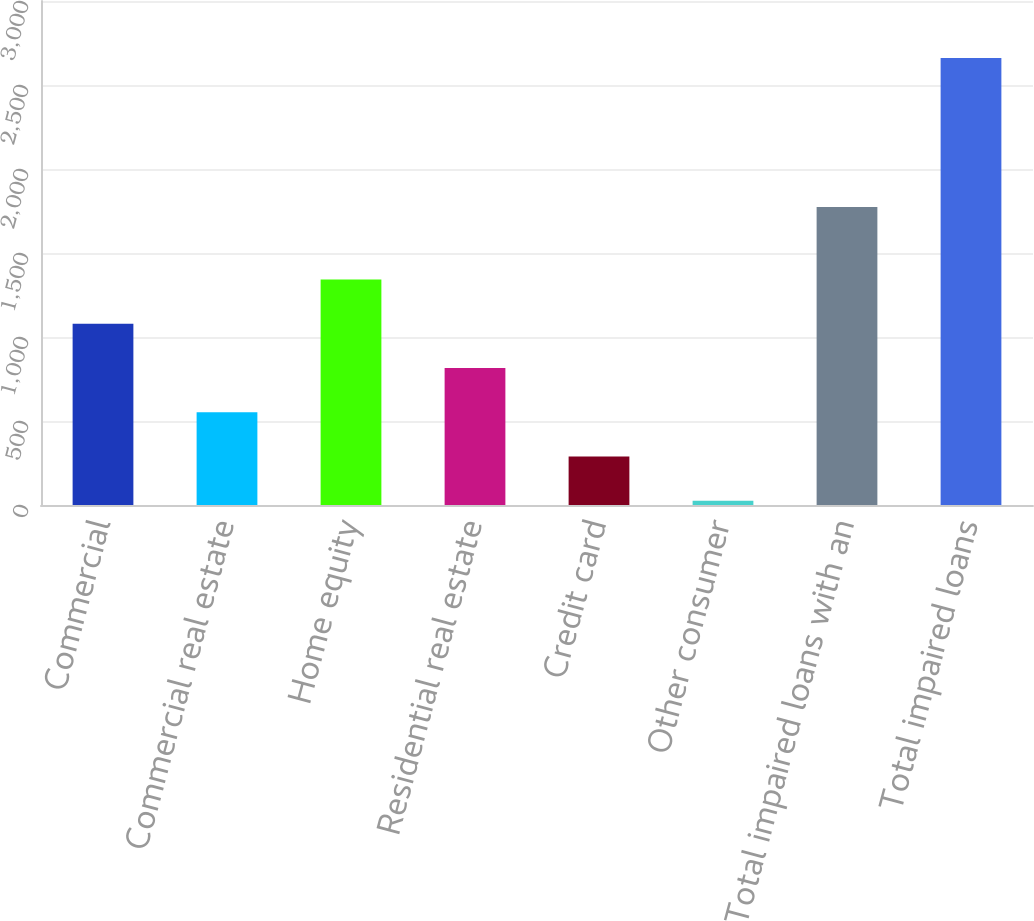Convert chart. <chart><loc_0><loc_0><loc_500><loc_500><bar_chart><fcel>Commercial<fcel>Commercial real estate<fcel>Home equity<fcel>Residential real estate<fcel>Credit card<fcel>Other consumer<fcel>Total impaired loans with an<fcel>Total impaired loans<nl><fcel>1079.6<fcel>552.8<fcel>1343<fcel>816.2<fcel>289.4<fcel>26<fcel>1774<fcel>2660<nl></chart> 